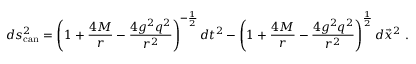Convert formula to latex. <formula><loc_0><loc_0><loc_500><loc_500>d s _ { c a n } ^ { 2 } = \left ( 1 + { \frac { 4 M } { r } } - { \frac { 4 g ^ { 2 } q ^ { 2 } } { r ^ { 2 } } } \right ) ^ { - { \frac { 1 } { 2 } } } d t ^ { 2 } - \left ( 1 + { \frac { 4 M } { r } } - { \frac { 4 g ^ { 2 } q ^ { 2 } } { r ^ { 2 } } } \right ) ^ { \frac { 1 } { 2 } } d \vec { x } ^ { 2 } \ .</formula> 